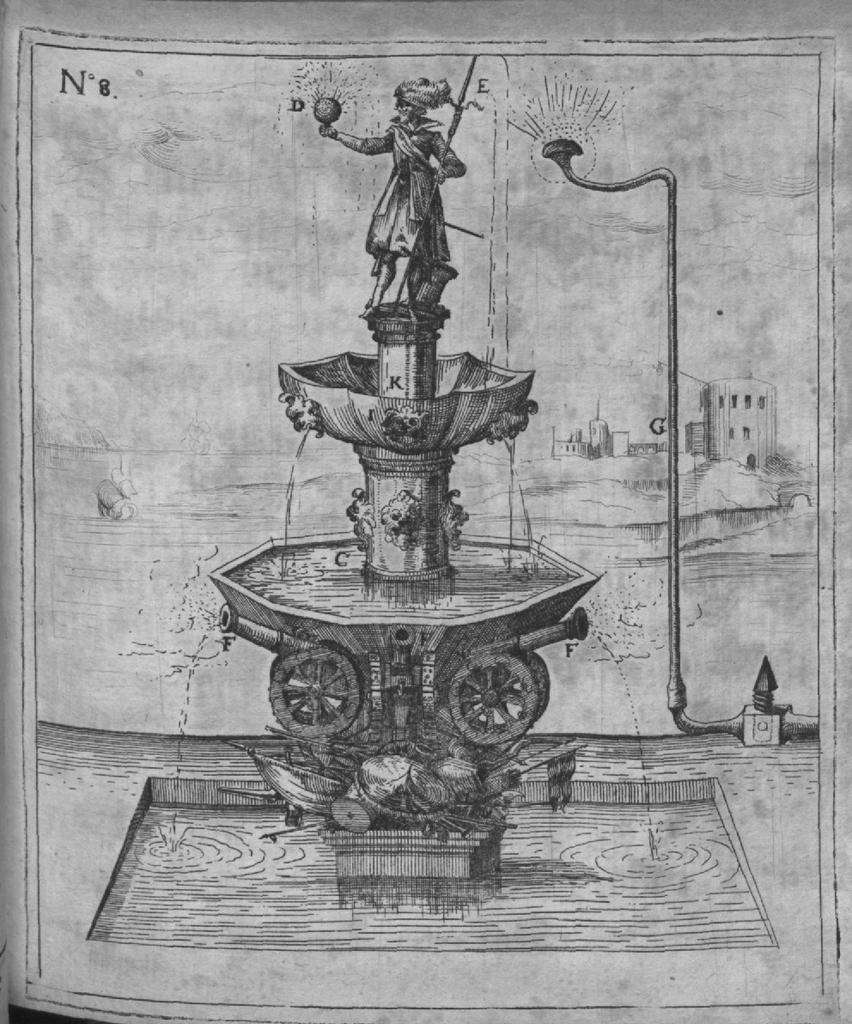What is depicted on the paper in the image? The paper contains a drawing or image of a fountain, wheels, water, a statue, a pole, and a water sprinkler. Can you describe the background of the image? There are buildings visible in the background of the image. What type of jewel is the statue holding in the image? There is no statue holding a jewel in the image; the paper only contains a drawing or image of a statue. 